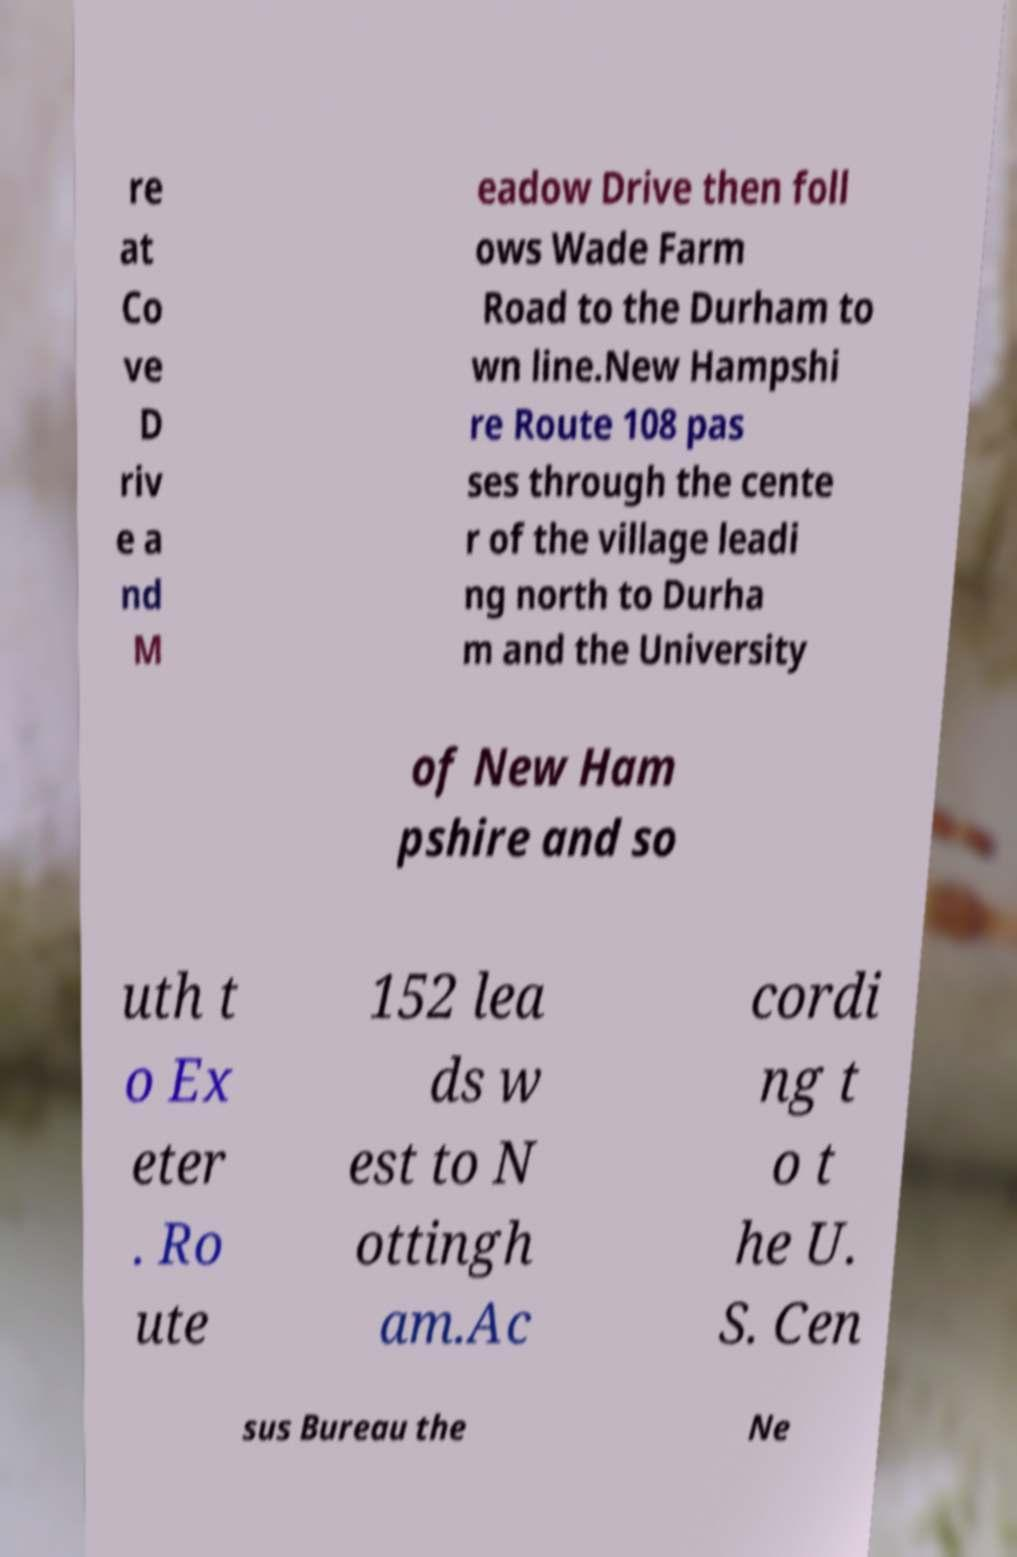Could you extract and type out the text from this image? re at Co ve D riv e a nd M eadow Drive then foll ows Wade Farm Road to the Durham to wn line.New Hampshi re Route 108 pas ses through the cente r of the village leadi ng north to Durha m and the University of New Ham pshire and so uth t o Ex eter . Ro ute 152 lea ds w est to N ottingh am.Ac cordi ng t o t he U. S. Cen sus Bureau the Ne 